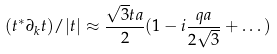Convert formula to latex. <formula><loc_0><loc_0><loc_500><loc_500>( t ^ { * } \partial _ { k } t ) / | t | \approx \frac { \sqrt { 3 } t a } { 2 } ( 1 - i \frac { q a } { 2 \sqrt { 3 } } + \dots )</formula> 